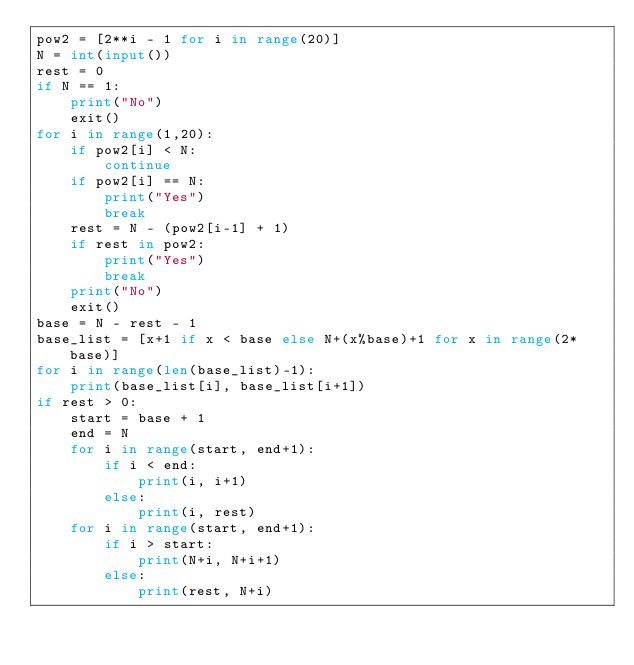<code> <loc_0><loc_0><loc_500><loc_500><_Python_>pow2 = [2**i - 1 for i in range(20)]
N = int(input())
rest = 0
if N == 1:
	print("No")
	exit()
for i in range(1,20):
	if pow2[i] < N:
		continue
	if pow2[i] == N:
		print("Yes")
		break
	rest = N - (pow2[i-1] + 1)
	if rest in pow2:
		print("Yes")
		break
	print("No")
	exit()
base = N - rest - 1
base_list = [x+1 if x < base else N+(x%base)+1 for x in range(2*base)]
for i in range(len(base_list)-1):
	print(base_list[i], base_list[i+1])
if rest > 0:
	start = base + 1
	end = N
	for i in range(start, end+1):
		if i < end:
			print(i, i+1)
		else:
			print(i, rest)
	for i in range(start, end+1):
		if i > start:
			print(N+i, N+i+1)
		else:
			print(rest, N+i)</code> 